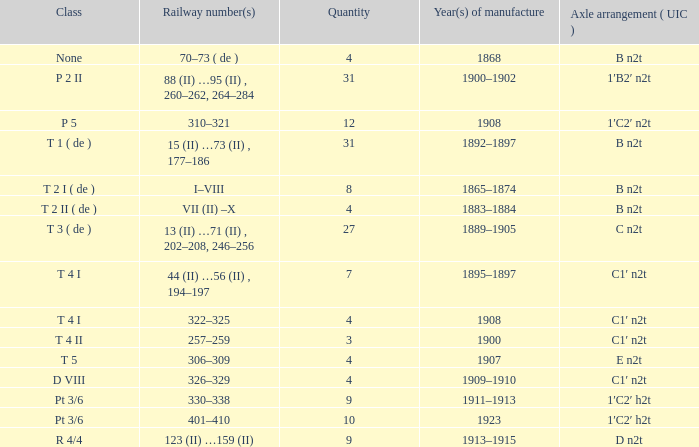Give me the full table as a dictionary. {'header': ['Class', 'Railway number(s)', 'Quantity', 'Year(s) of manufacture', 'Axle arrangement ( UIC )'], 'rows': [['None', '70–73 ( de )', '4', '1868', 'B n2t'], ['P 2 II', '88 (II) …95 (II) , 260–262, 264–284', '31', '1900–1902', '1′B2′ n2t'], ['P 5', '310–321', '12', '1908', '1′C2′ n2t'], ['T 1 ( de )', '15 (II) …73 (II) , 177–186', '31', '1892–1897', 'B n2t'], ['T 2 I ( de )', 'I–VIII', '8', '1865–1874', 'B n2t'], ['T 2 II ( de )', 'VII (II) –X', '4', '1883–1884', 'B n2t'], ['T 3 ( de )', '13 (II) …71 (II) , 202–208, 246–256', '27', '1889–1905', 'C n2t'], ['T 4 I', '44 (II) …56 (II) , 194–197', '7', '1895–1897', 'C1′ n2t'], ['T 4 I', '322–325', '4', '1908', 'C1′ n2t'], ['T 4 II', '257–259', '3', '1900', 'C1′ n2t'], ['T 5', '306–309', '4', '1907', 'E n2t'], ['D VIII', '326–329', '4', '1909–1910', 'C1′ n2t'], ['Pt 3/6', '330–338', '9', '1911–1913', '1′C2′ h2t'], ['Pt 3/6', '401–410', '10', '1923', '1′C2′ h2t'], ['R 4/4', '123 (II) …159 (II)', '9', '1913–1915', 'D n2t']]} What year was the b n2t axle arrangement, which has a quantity of 31, manufactured? 1892–1897. 